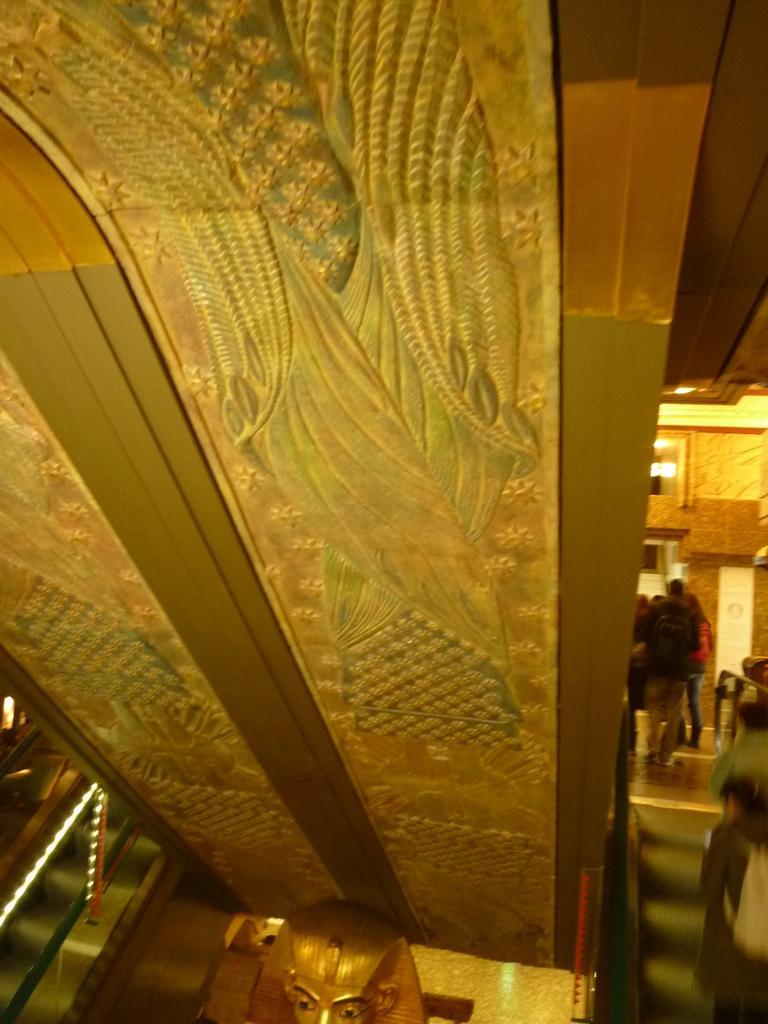Please provide a concise description of this image. This looks like a pillar with a design on it. I think this is an egyptian sculpture, which is gold in color. I can see groups of people standing. This looks like a wall. 